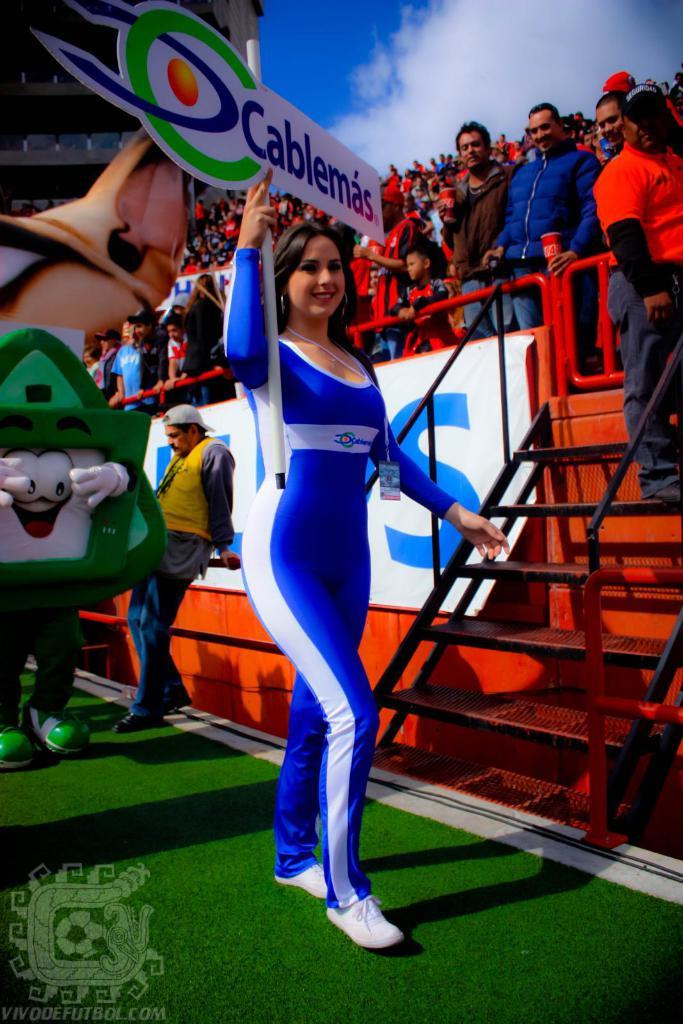Does she work for cablemas?
Your answer should be very brief. Yes. Whats the big blue letter on the sign?
Provide a short and direct response. S. 